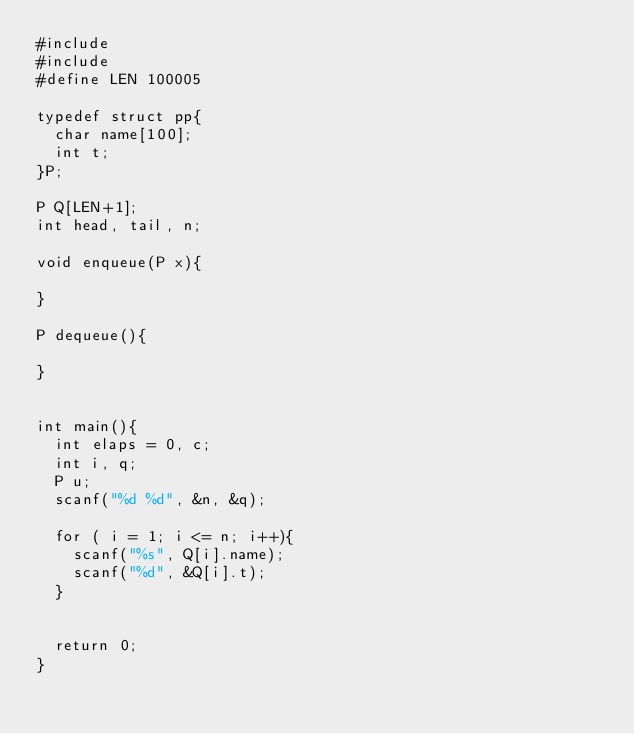Convert code to text. <code><loc_0><loc_0><loc_500><loc_500><_C_>#include
#include
#define LEN 100005

typedef struct pp{
  char name[100];
  int t;
}P;

P Q[LEN+1];
int head, tail, n;

void enqueue(P x){

}

P dequeue(){

}


int main(){
  int elaps = 0, c;
  int i, q;
  P u;
  scanf("%d %d", &n, &q);

  for ( i = 1; i <= n; i++){
    scanf("%s", Q[i].name);
    scanf("%d", &Q[i].t);
  }

  
  return 0;
}
</code> 